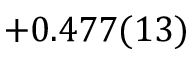Convert formula to latex. <formula><loc_0><loc_0><loc_500><loc_500>+ 0 . 4 7 7 ( 1 3 )</formula> 